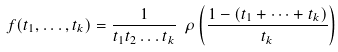Convert formula to latex. <formula><loc_0><loc_0><loc_500><loc_500>f ( t _ { 1 } , \dots , t _ { k } ) = \frac { 1 } { t _ { 1 } t _ { 2 } \dots t _ { k } } \ \rho \left ( \frac { 1 - ( t _ { 1 } + \dots + t _ { k } ) } { t _ { k } } \right )</formula> 